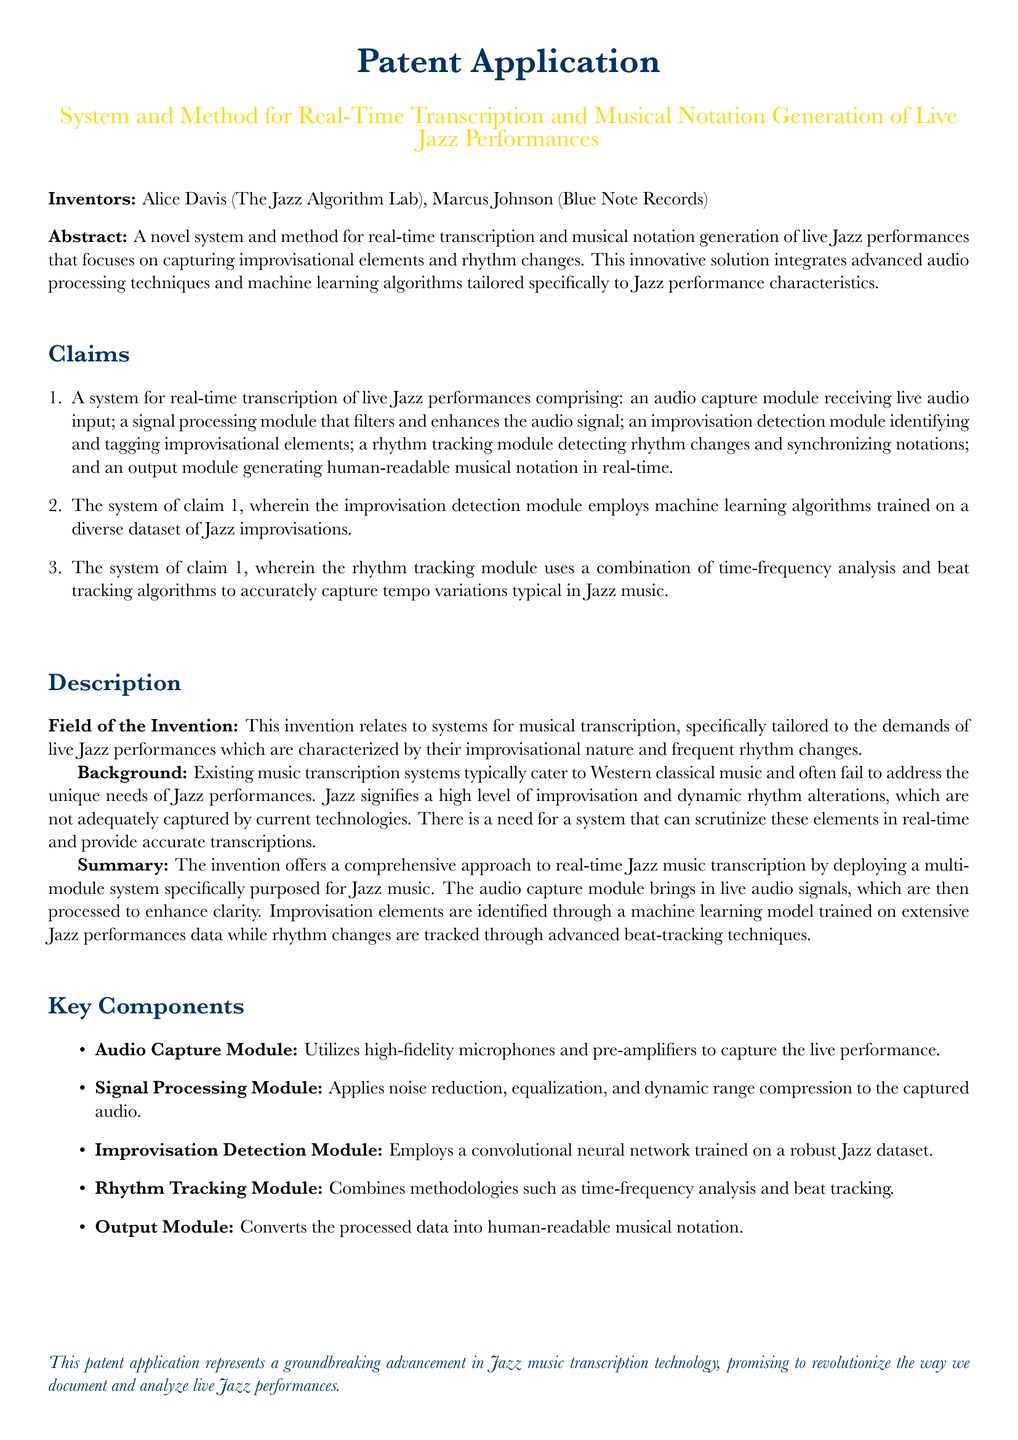What is the title of the patent application? The title is specified in the document as the name of the invention.
Answer: System and Method for Real-Time Transcription and Musical Notation Generation of Live Jazz Performances Who are the inventors of the system? The inventors are listed in the document with their respective affiliations.
Answer: Alice Davis, Marcus Johnson What is the primary focus of the system? The primary focus is mentioned in the abstract and description sections of the document.
Answer: Capturing improvisational elements and rhythm changes What does the improvisation detection module utilize for detection? The document specifies the technology used in the improvisation detection module.
Answer: Machine learning algorithms How many key components are mentioned in the document? The document lists several components, and the question asks for the count of these components.
Answer: Five What unique challenges does this system address? The challenges are outlined in the background section of the document regarding music genres.
Answer: Unique needs of Jazz performances What type of neural network is used in the improvisation detection module? The specific type of neural network is mentioned in the key components section.
Answer: Convolutional neural network What module is responsible for generating human-readable musical notation? The document identifies which specific module handles the output.
Answer: Output Module 